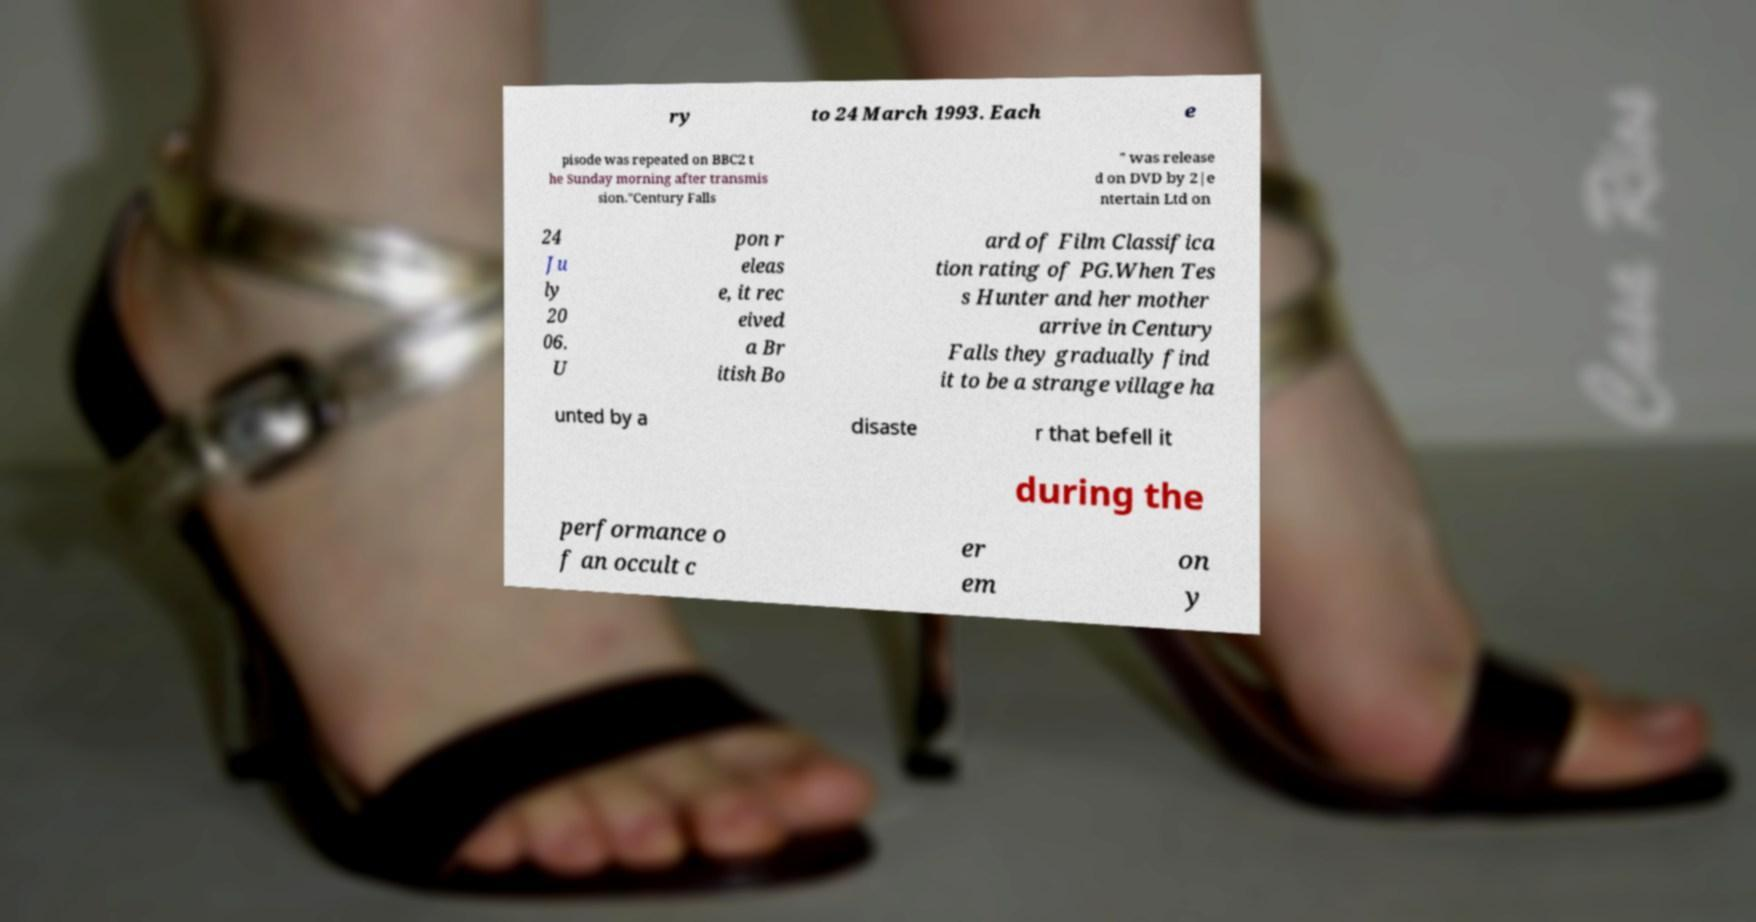Please read and relay the text visible in this image. What does it say? ry to 24 March 1993. Each e pisode was repeated on BBC2 t he Sunday morning after transmis sion."Century Falls " was release d on DVD by 2|e ntertain Ltd on 24 Ju ly 20 06. U pon r eleas e, it rec eived a Br itish Bo ard of Film Classifica tion rating of PG.When Tes s Hunter and her mother arrive in Century Falls they gradually find it to be a strange village ha unted by a disaste r that befell it during the performance o f an occult c er em on y 